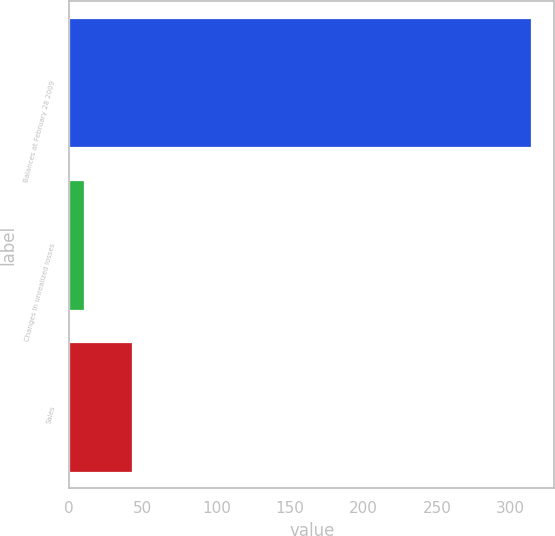Convert chart. <chart><loc_0><loc_0><loc_500><loc_500><bar_chart><fcel>Balances at February 28 2009<fcel>Changes in unrealized losses<fcel>Sales<nl><fcel>314<fcel>10<fcel>43<nl></chart> 